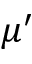<formula> <loc_0><loc_0><loc_500><loc_500>\mu ^ { \prime }</formula> 